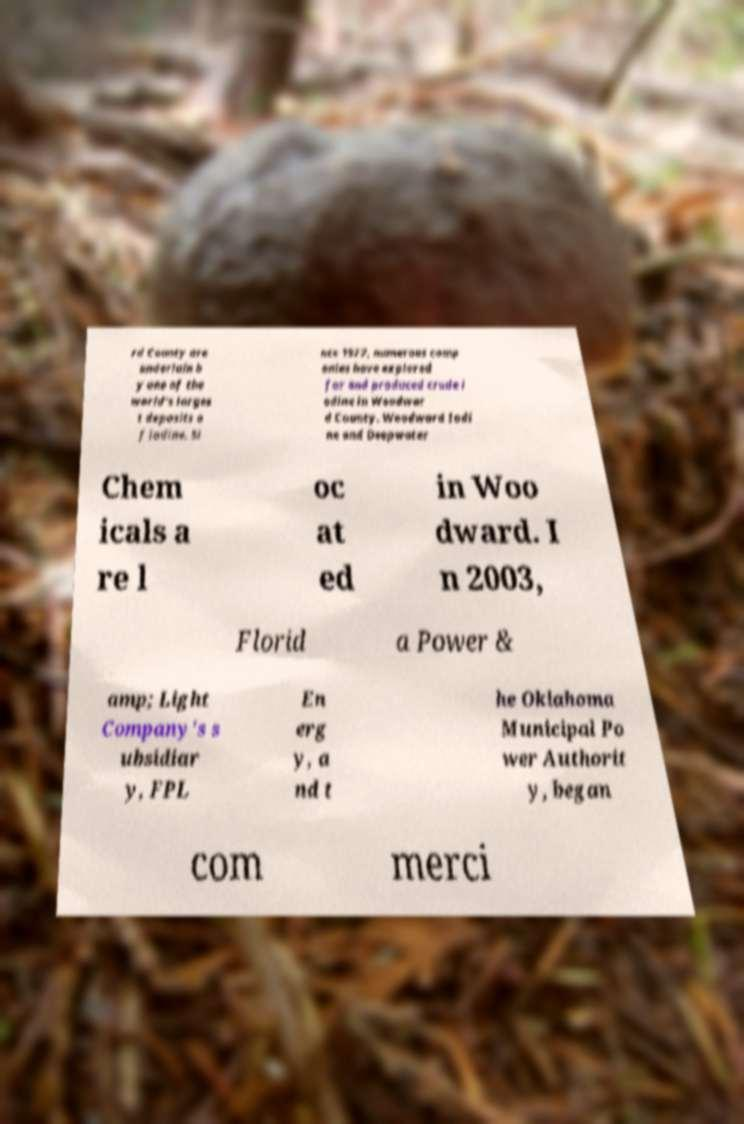Can you accurately transcribe the text from the provided image for me? rd County are underlain b y one of the world's larges t deposits o f iodine. Si nce 1977, numerous comp anies have explored for and produced crude i odine in Woodwar d County. Woodward Iodi ne and Deepwater Chem icals a re l oc at ed in Woo dward. I n 2003, Florid a Power & amp; Light Company's s ubsidiar y, FPL En erg y, a nd t he Oklahoma Municipal Po wer Authorit y, began com merci 